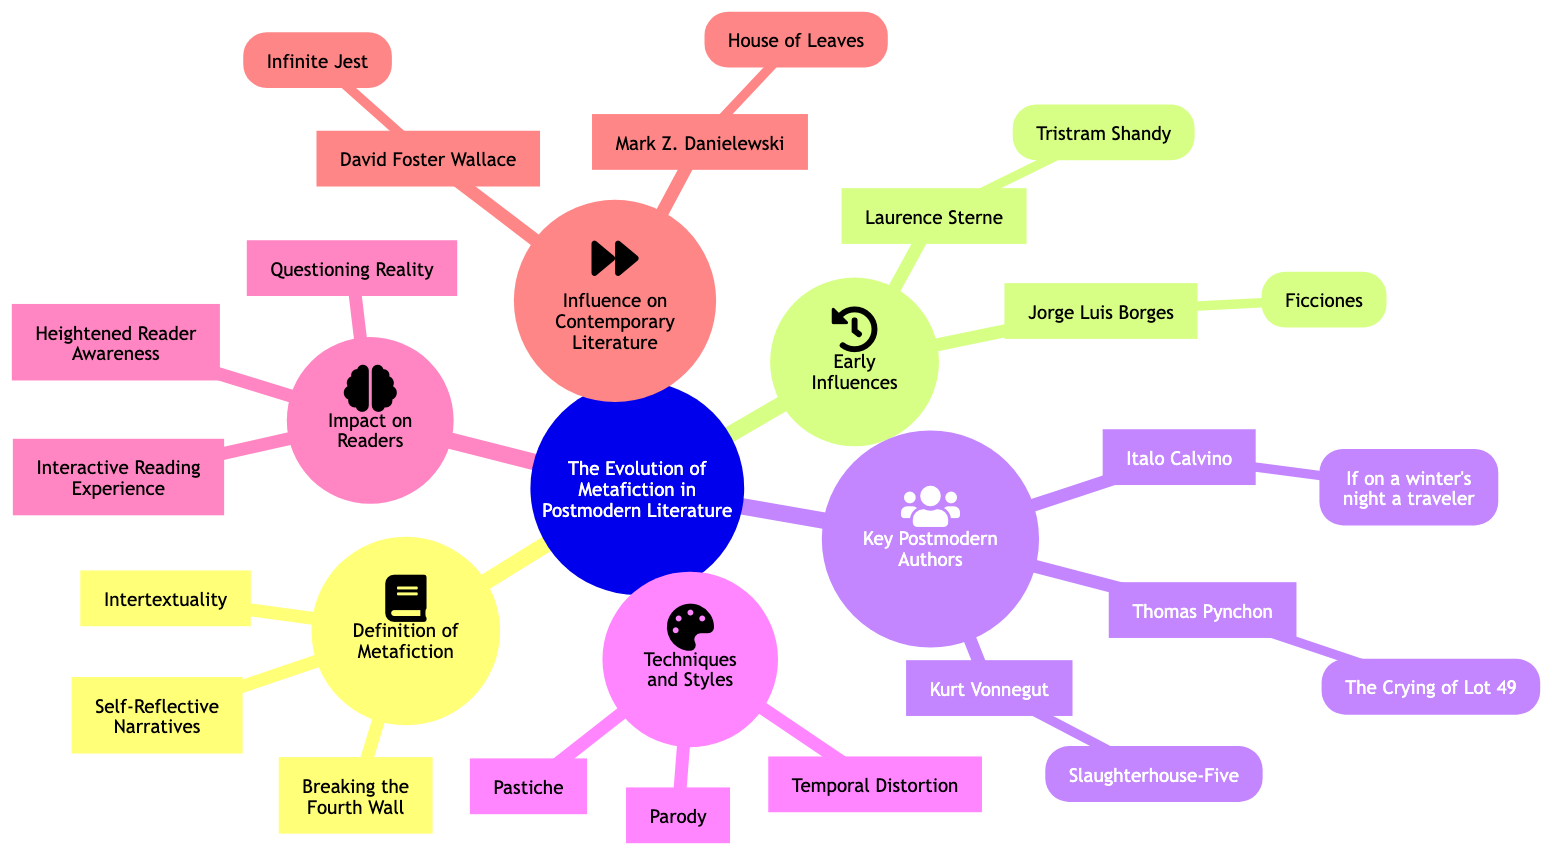What is one technique used in metafiction? The diagram lists three techniques under "Techniques and Styles." One of them is "Parody."
Answer: Parody How many key postmodern authors are mentioned? Under "Key Postmodern Authors," there are three authors listed: Kurt Vonnegut, Italo Calvino, and Thomas Pynchon.
Answer: 3 Which author wrote "Infinite Jest"? The name "David Foster Wallace" is associated with "Infinite Jest" under "Influence on Contemporary Literature."
Answer: David Foster Wallace What is a characteristic of metafiction that enhances reader engagement? The "Impact on Readers" section includes "Interactive Reading Experience" as a characteristic of metafiction that enhances reader engagement.
Answer: Interactive Reading Experience Which work is associated with Jorge Luis Borges? In the "Early Influences" section, "Ficciones" is listed as the work associated with Jorge Luis Borges.
Answer: Ficciones Which technique is described as combining various genres and styles? The techniques include "Pastiche," which refers to combining various genres and styles in narrative.
Answer: Pastiche What does breaking the fourth wall refer to in metafiction? "Breaking the Fourth Wall" is listed under "Definition of Metafiction," indicating it refers to the technique where characters directly address the audience.
Answer: Breaking the Fourth Wall How does metafiction affect readers' perception of reality? One of the impacts mentioned is "Questioning Reality," highlighting how metafiction prompts readers to reconsider their perceptions of reality.
Answer: Questioning Reality Which novel by Thomas Pynchon is highlighted in the diagram? "The Crying of Lot 49" is the work associated with Thomas Pynchon under "Key Postmodern Authors."
Answer: The Crying of Lot 49 